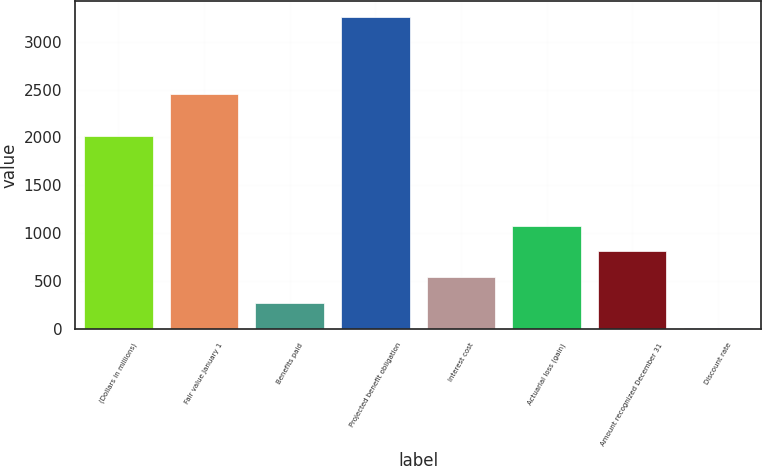Convert chart to OTSL. <chart><loc_0><loc_0><loc_500><loc_500><bar_chart><fcel>(Dollars in millions)<fcel>Fair value January 1<fcel>Benefits paid<fcel>Projected benefit obligation<fcel>Interest cost<fcel>Actuarial loss (gain)<fcel>Amount recognized December 31<fcel>Discount rate<nl><fcel>2014<fcel>2457<fcel>272<fcel>3262.32<fcel>540.44<fcel>1077.32<fcel>808.88<fcel>3.56<nl></chart> 